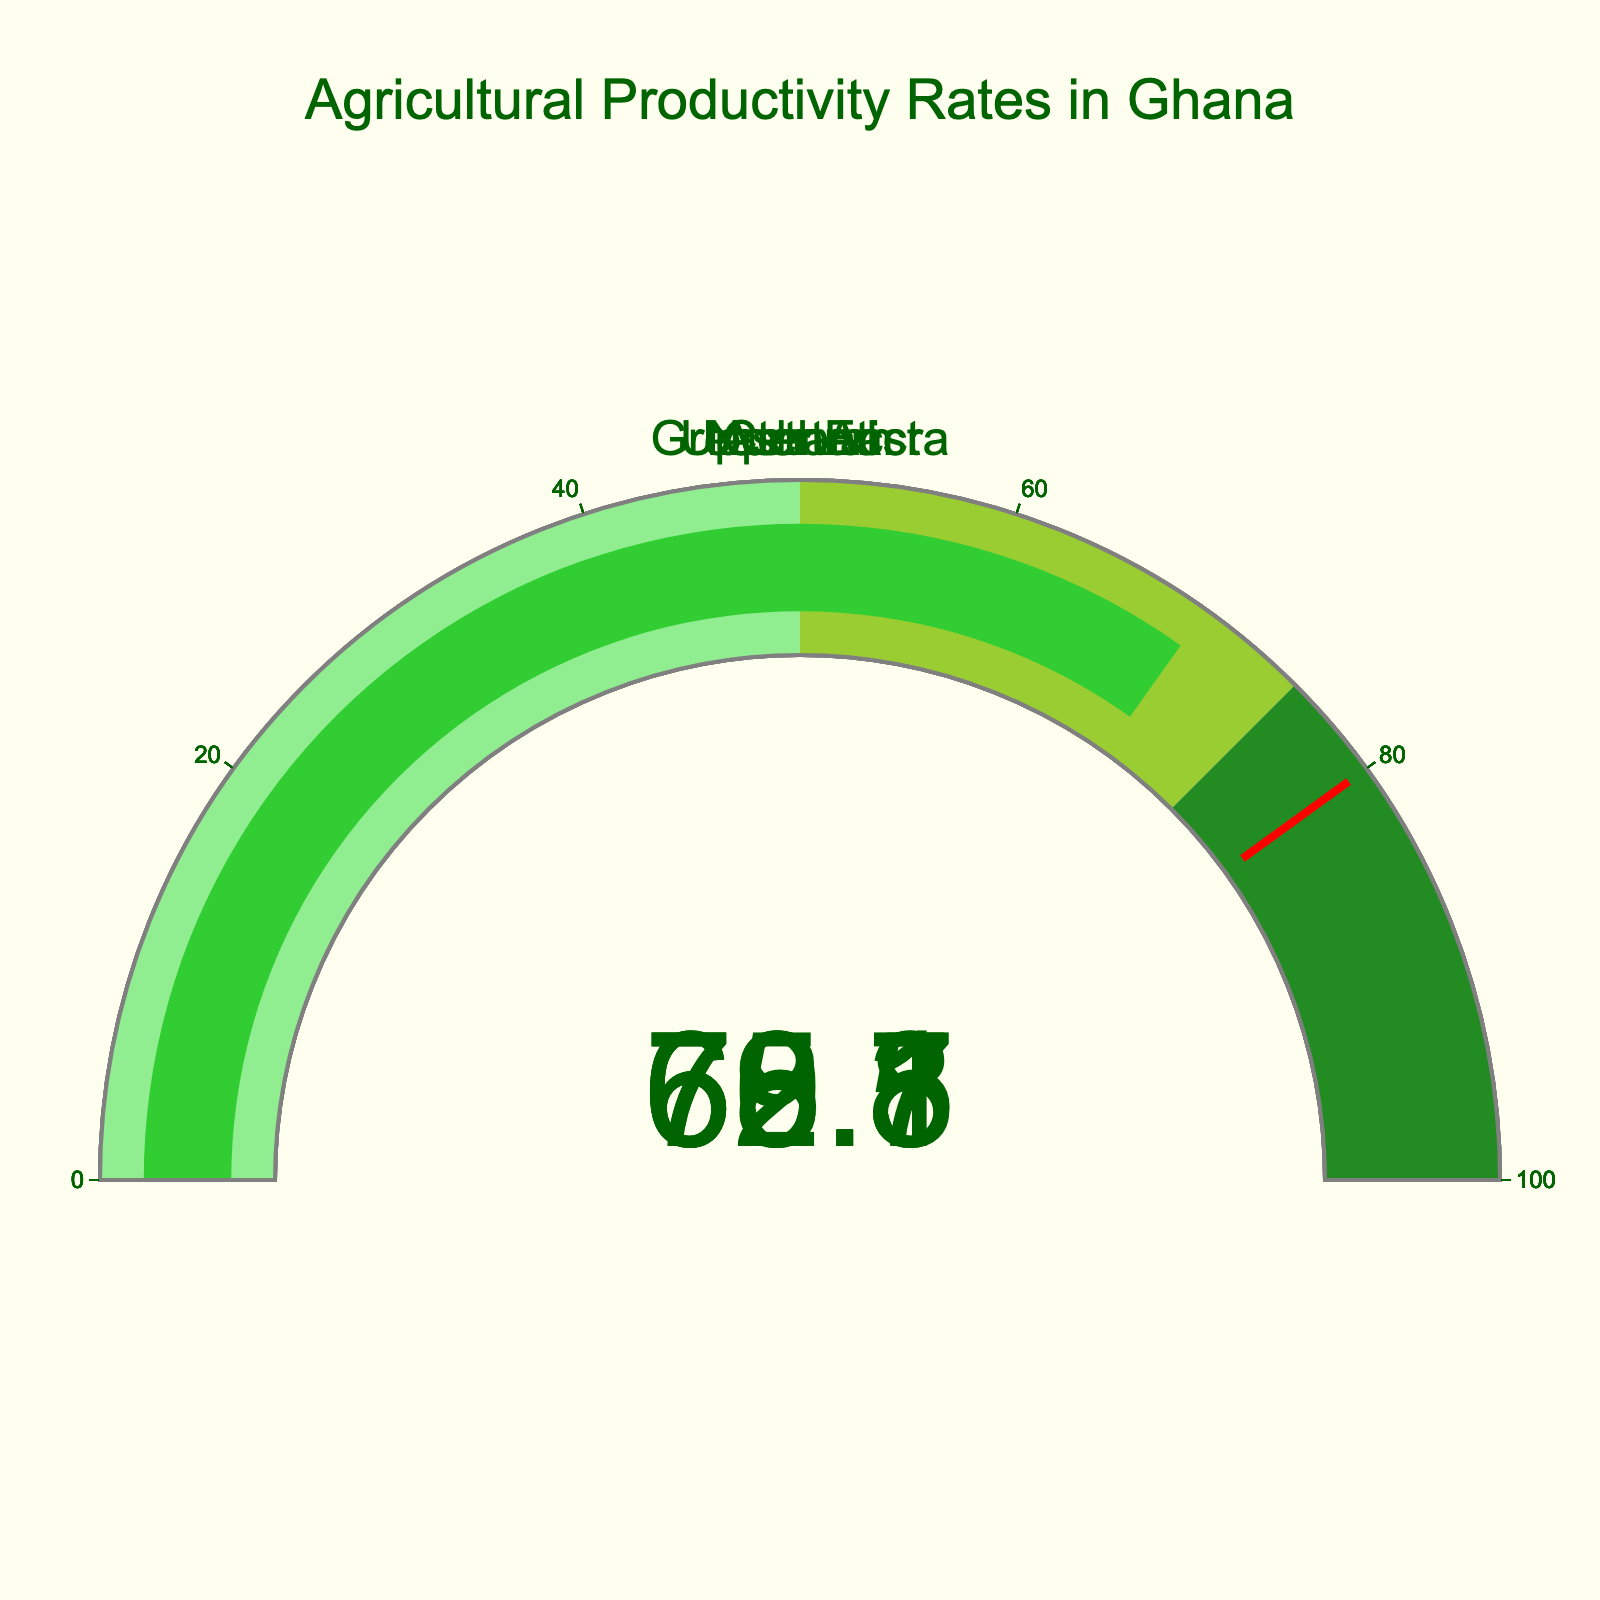What's the range of the gauge’s axis? The gauge's axis range is indicated by the range markers on the figure. The tick marks indicate that the range is from 0 to 100.
Answer: 0 to 100 How many regions are displayed in the figure? Each gauge represents a region, and each title corresponds to one of the regions. Counting the number of titles, we see there are 5 regions: Upper East, Greater Accra, Northern, Ashanti, and Central.
Answer: 5 Which region has the highest agricultural productivity rate? Looking at the values displayed on each gauge, Greater Accra has the highest agricultural productivity rate with a value of 72.3.
Answer: Greater Accra Which region has the lowest agricultural productivity rate? By comparing the values on each gauge, the Northern region has the lowest agricultural productivity rate with a value of 65.8.
Answer: Northern What is the difference in agricultural productivity rate between Greater Accra and Northern? To find the difference, subtract the Northern region's value (65.8) from Greater Accra's value (72.3). 72.3 - 65.8 = 6.5
Answer: 6.5 What's the average agricultural productivity rate of all the regions displayed? Sum all the values and divide by the number of regions: (68.5 + 72.3 + 65.8 + 70.1 + 69.7) / 5 = 346.4 / 5 = 69.28
Answer: 69.28 Does any region have an agricultural productivity rate above 75? Looking at the values displayed, none of the regions has a value above 75. The highest value is 72.3 for Greater Accra.
Answer: No What's the median agricultural productivity rate among the regions? To find the median, list the values in ascending order: 65.8, 68.5, 69.7, 70.1, 72.3. The median is the middle value, which is 69.7.
Answer: 69.7 Which region's agricultural productivity rate is closest to the threshold value of 80? The threshold line is set at 80, and the region with the value closest to this without exceeding it is Greater Accra, with a rate of 72.3.
Answer: Greater Accra If the average agricultural productivity rate required for satisfactory performance is 70, which regions fall below this average? Compare each region's rate with the satisfactory performance rate of 70. The regions with rates below 70 are Upper East (68.5), Northern (65.8), and Central (69.7).
Answer: Upper East, Northern, Central 